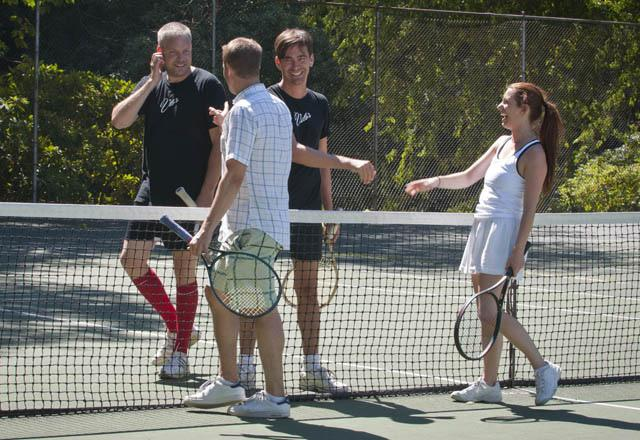What is the relationship of the man wearing white checker shirt to the woman wearing white skirt in this situation?

Choices:
A) coworker
B) competitor
C) teammate
D) coach teammate 